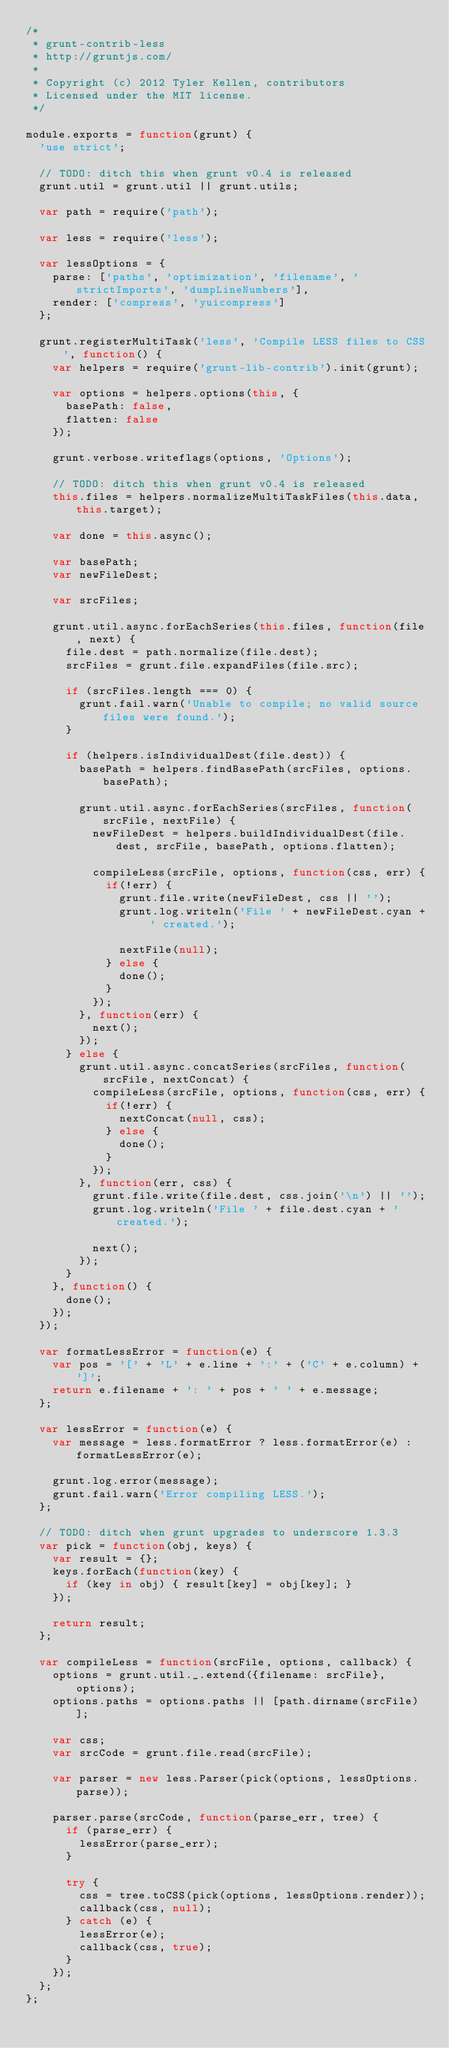<code> <loc_0><loc_0><loc_500><loc_500><_JavaScript_>/*
 * grunt-contrib-less
 * http://gruntjs.com/
 *
 * Copyright (c) 2012 Tyler Kellen, contributors
 * Licensed under the MIT license.
 */

module.exports = function(grunt) {
  'use strict';

  // TODO: ditch this when grunt v0.4 is released
  grunt.util = grunt.util || grunt.utils;

  var path = require('path');

  var less = require('less');

  var lessOptions = {
    parse: ['paths', 'optimization', 'filename', 'strictImports', 'dumpLineNumbers'],
    render: ['compress', 'yuicompress']
  };

  grunt.registerMultiTask('less', 'Compile LESS files to CSS', function() {
    var helpers = require('grunt-lib-contrib').init(grunt);

    var options = helpers.options(this, {
      basePath: false,
      flatten: false
    });

    grunt.verbose.writeflags(options, 'Options');

    // TODO: ditch this when grunt v0.4 is released
    this.files = helpers.normalizeMultiTaskFiles(this.data, this.target);

    var done = this.async();

    var basePath;
    var newFileDest;

    var srcFiles;

    grunt.util.async.forEachSeries(this.files, function(file, next) {
      file.dest = path.normalize(file.dest);
      srcFiles = grunt.file.expandFiles(file.src);

      if (srcFiles.length === 0) {
        grunt.fail.warn('Unable to compile; no valid source files were found.');
      }

      if (helpers.isIndividualDest(file.dest)) {
        basePath = helpers.findBasePath(srcFiles, options.basePath);

        grunt.util.async.forEachSeries(srcFiles, function(srcFile, nextFile) {
          newFileDest = helpers.buildIndividualDest(file.dest, srcFile, basePath, options.flatten);

          compileLess(srcFile, options, function(css, err) {
            if(!err) {
              grunt.file.write(newFileDest, css || '');
              grunt.log.writeln('File ' + newFileDest.cyan + ' created.');

              nextFile(null);
            } else {
              done();
            }
          });
        }, function(err) {
          next();
        });
      } else {
        grunt.util.async.concatSeries(srcFiles, function(srcFile, nextConcat) {
          compileLess(srcFile, options, function(css, err) {
            if(!err) {
              nextConcat(null, css);
            } else {
              done();
            }
          });
        }, function(err, css) {
          grunt.file.write(file.dest, css.join('\n') || '');
          grunt.log.writeln('File ' + file.dest.cyan + ' created.');

          next();
        });
      }
    }, function() {
      done();
    });
  });

  var formatLessError = function(e) {
    var pos = '[' + 'L' + e.line + ':' + ('C' + e.column) + ']';
    return e.filename + ': ' + pos + ' ' + e.message;
  };

  var lessError = function(e) {
    var message = less.formatError ? less.formatError(e) : formatLessError(e);

    grunt.log.error(message);
    grunt.fail.warn('Error compiling LESS.');
  };

  // TODO: ditch when grunt upgrades to underscore 1.3.3
  var pick = function(obj, keys) {
    var result = {};
    keys.forEach(function(key) {
      if (key in obj) { result[key] = obj[key]; }
    });

    return result;
  };

  var compileLess = function(srcFile, options, callback) {
    options = grunt.util._.extend({filename: srcFile}, options);
    options.paths = options.paths || [path.dirname(srcFile)];

    var css;
    var srcCode = grunt.file.read(srcFile);

    var parser = new less.Parser(pick(options, lessOptions.parse));

    parser.parse(srcCode, function(parse_err, tree) {
      if (parse_err) {
        lessError(parse_err);
      }

      try {
        css = tree.toCSS(pick(options, lessOptions.render));
        callback(css, null);
      } catch (e) {
        lessError(e);
        callback(css, true);
      }
    });
  };
};
</code> 